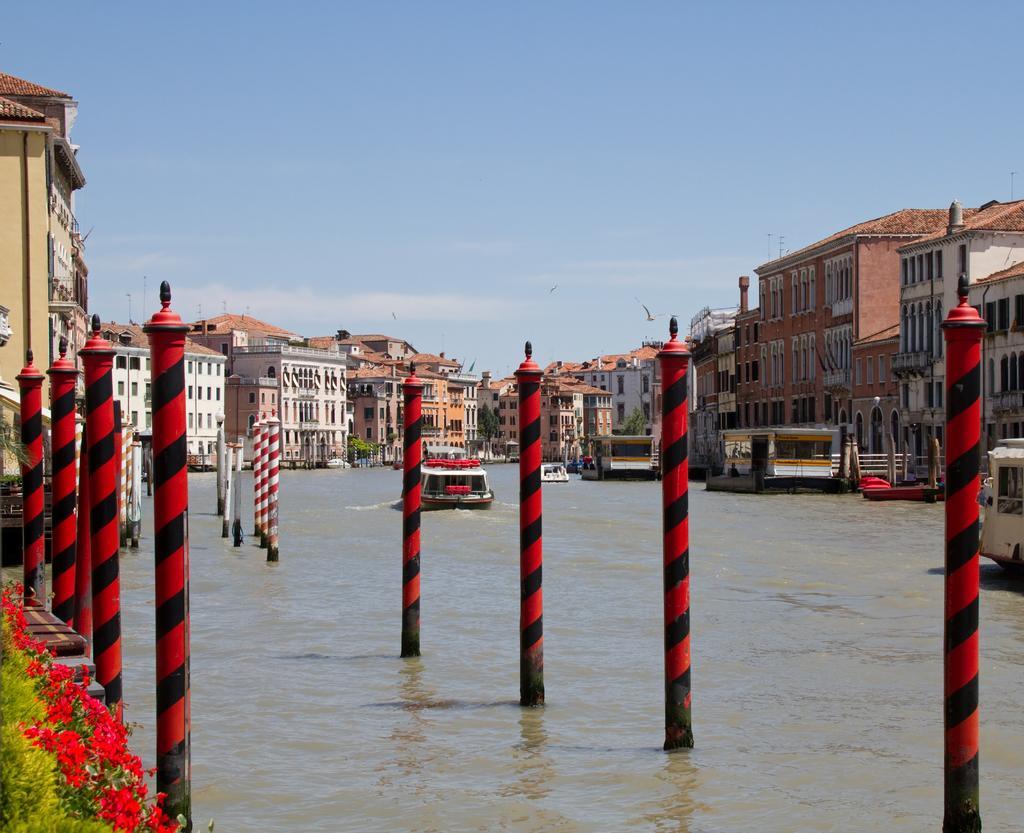How would you summarize this image in a sentence or two? In this picture we can see poles, flowers, boats on the water, buildings with windows and some objects and in the background we can see the sky. 